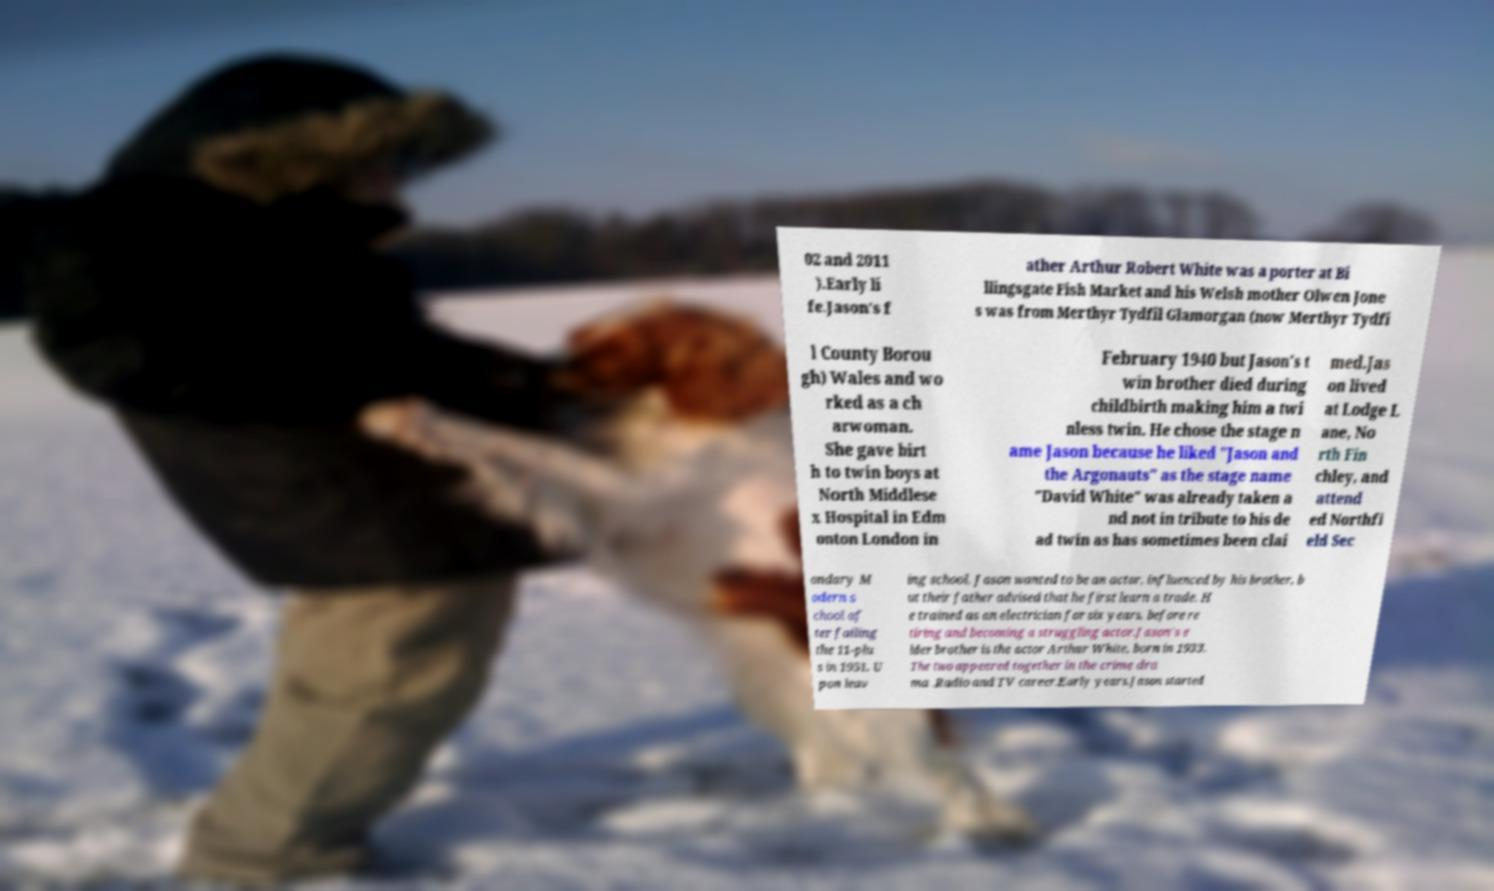Please read and relay the text visible in this image. What does it say? 02 and 2011 ).Early li fe.Jason's f ather Arthur Robert White was a porter at Bi llingsgate Fish Market and his Welsh mother Olwen Jone s was from Merthyr Tydfil Glamorgan (now Merthyr Tydfi l County Borou gh) Wales and wo rked as a ch arwoman. She gave birt h to twin boys at North Middlese x Hospital in Edm onton London in February 1940 but Jason's t win brother died during childbirth making him a twi nless twin. He chose the stage n ame Jason because he liked "Jason and the Argonauts" as the stage name "David White" was already taken a nd not in tribute to his de ad twin as has sometimes been clai med.Jas on lived at Lodge L ane, No rth Fin chley, and attend ed Northfi eld Sec ondary M odern s chool af ter failing the 11-plu s in 1951. U pon leav ing school, Jason wanted to be an actor, influenced by his brother, b ut their father advised that he first learn a trade. H e trained as an electrician for six years, before re tiring and becoming a struggling actor.Jason's e lder brother is the actor Arthur White, born in 1933. The two appeared together in the crime dra ma .Radio and TV career.Early years.Jason started 